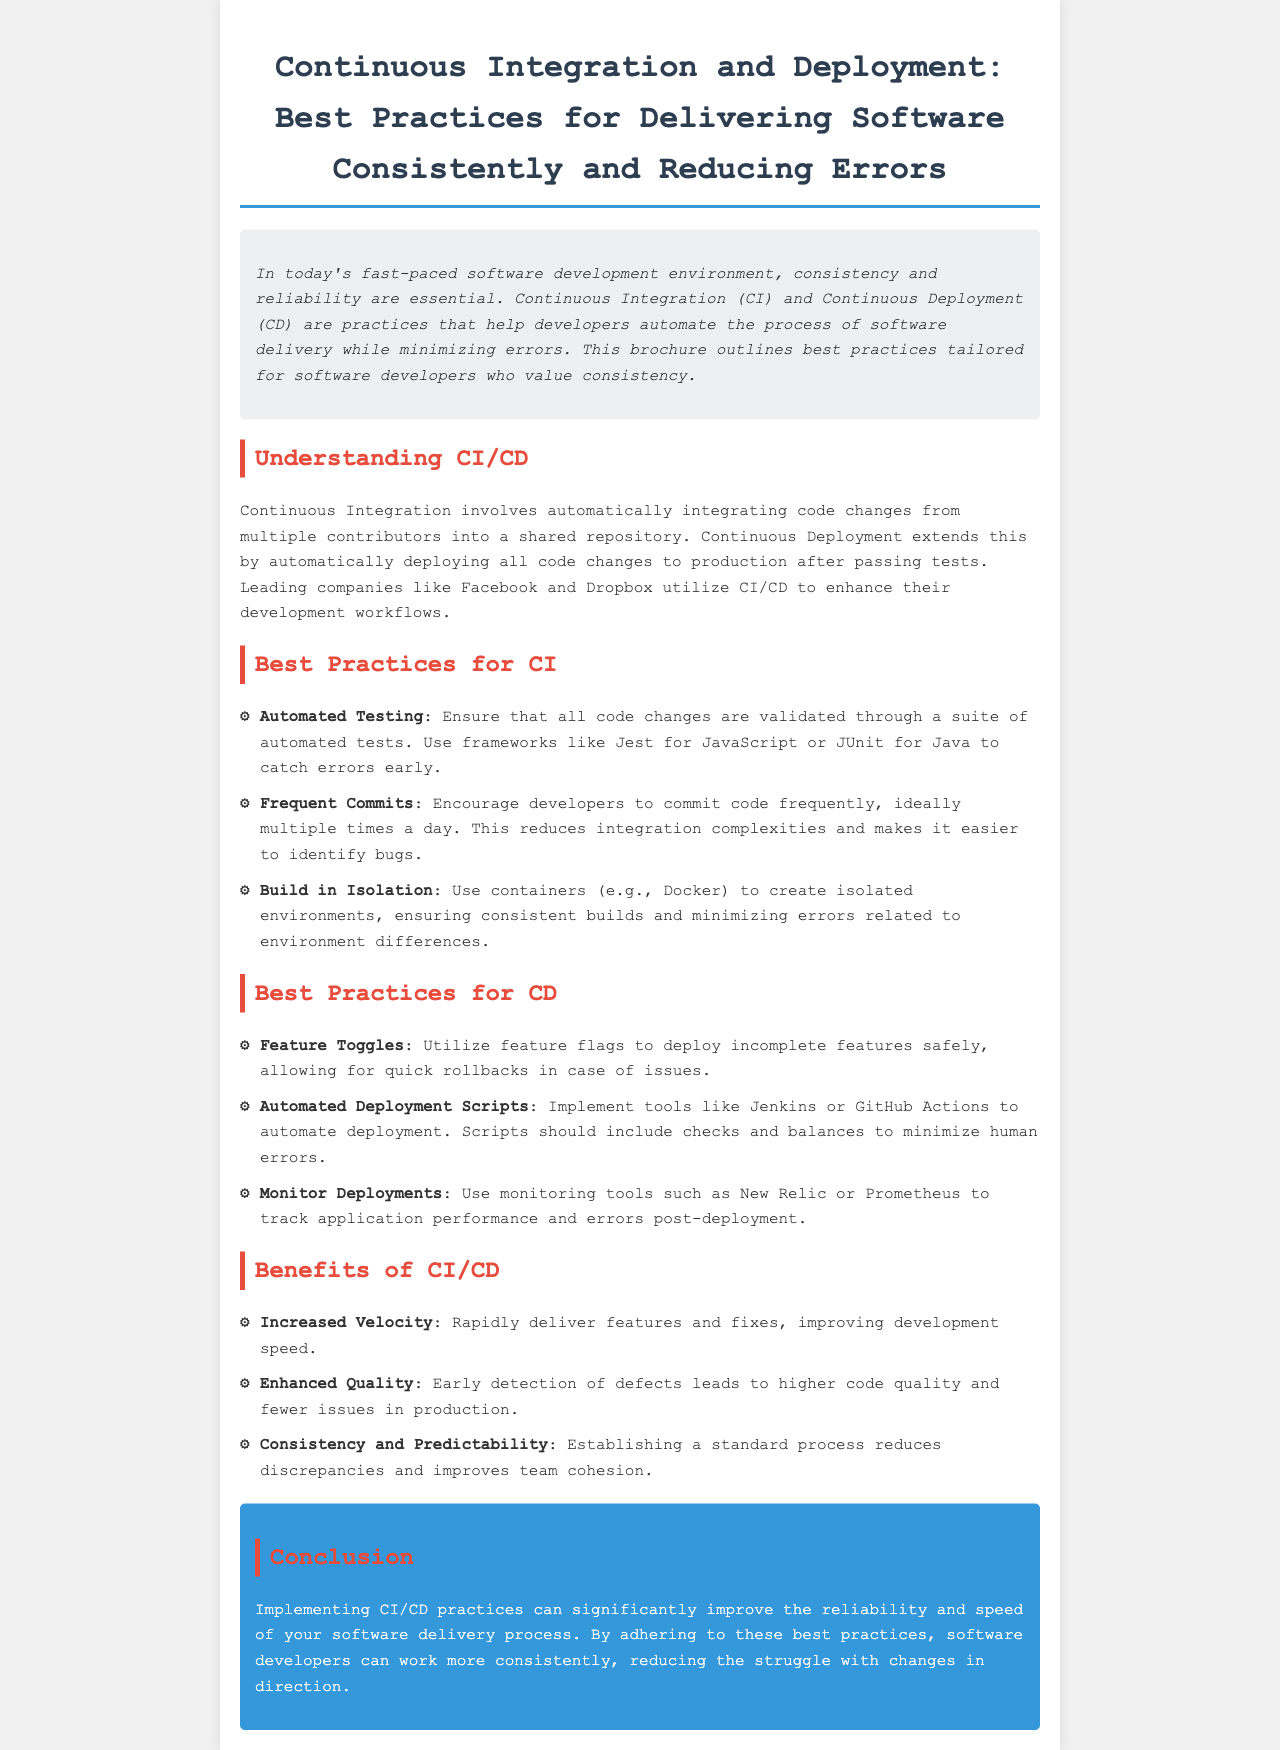What is the title of the brochure? The title of the brochure is stated prominently at the top of the document.
Answer: Continuous Integration and Deployment: Best Practices for Delivering Software Consistently and Reducing Errors What is the purpose of Continuous Integration? The document mentions that Continuous Integration involves integrating code changes into a shared repository.
Answer: Automatically integrating code changes Which tool is recommended for automated testing in Java? The document lists examples of frameworks used for automated testing in Java.
Answer: JUnit What is one benefit of CI/CD mentioned in the brochure? The brochure outlines various benefits of CI/CD, focusing on specific advantages.
Answer: Increased Velocity What should developers use to create isolated environments? The document recommends a technology to ensure consistent builds, which can minimize errors.
Answer: Containers (e.g., Docker) How often should developers commit code according to the best practices? The document suggests a frequency that minimizes integration complexities.
Answer: Multiple times a day What is a feature toggle used for? The brochure describes the function of feature toggles in the context of deployment.
Answer: Deploy incomplete features safely What is the color of the conclusion section? The brochure describes the background color of the conclusion area for emphasis.
Answer: Blue What monitoring tool is mentioned for tracking application performance? The document specifies tools for monitoring after deployment.
Answer: New Relic 